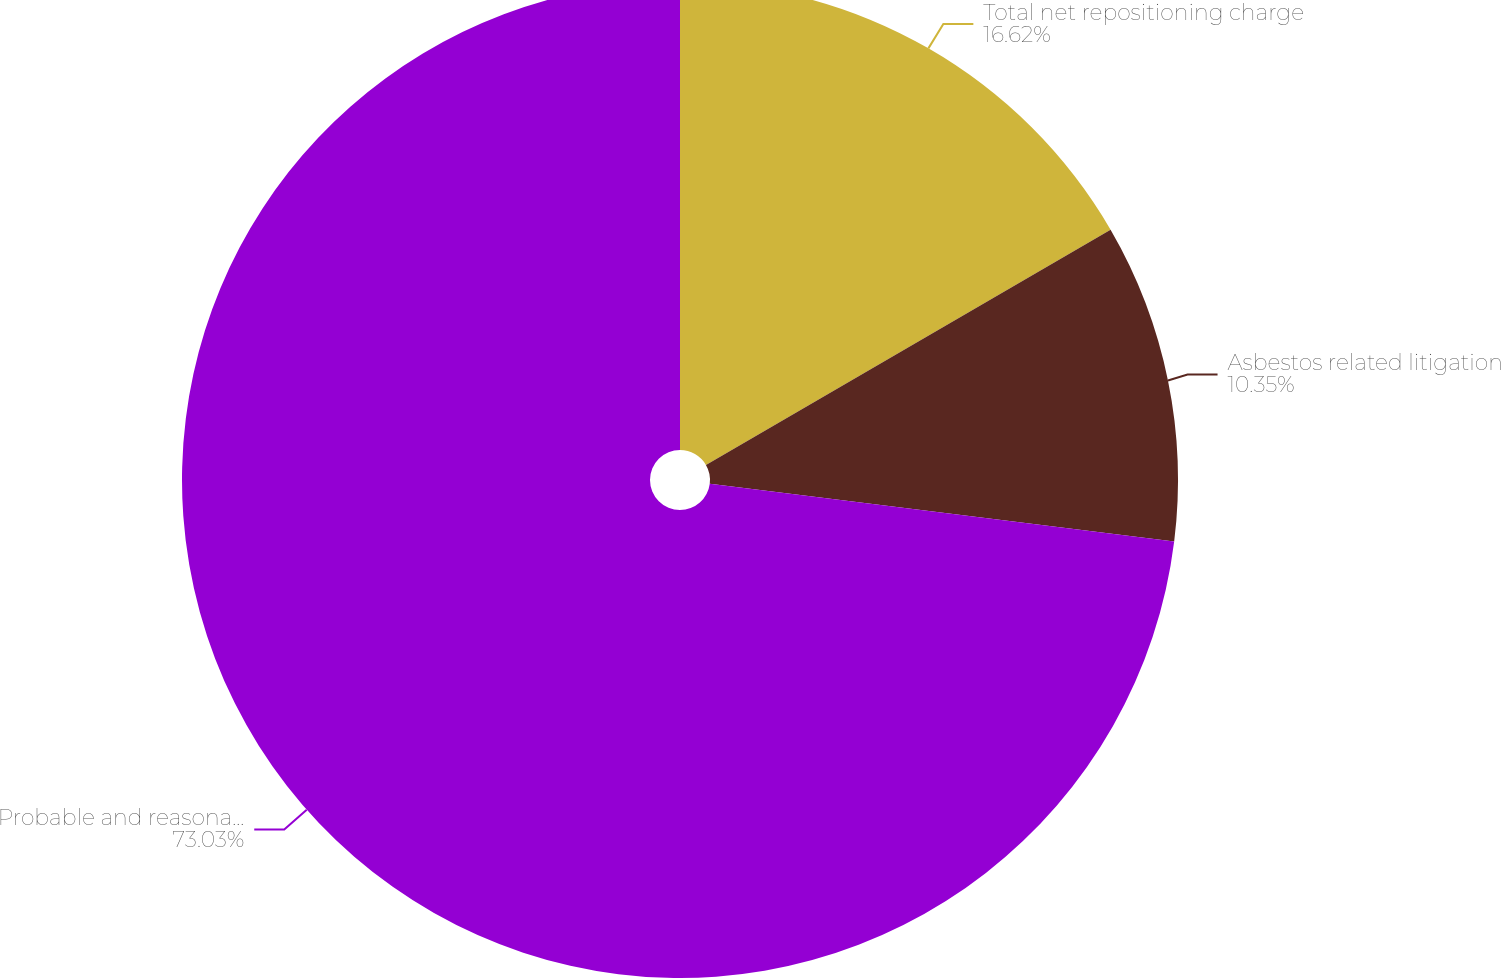Convert chart. <chart><loc_0><loc_0><loc_500><loc_500><pie_chart><fcel>Total net repositioning charge<fcel>Asbestos related litigation<fcel>Probable and reasonably<nl><fcel>16.62%<fcel>10.35%<fcel>73.02%<nl></chart> 